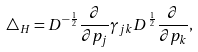Convert formula to latex. <formula><loc_0><loc_0><loc_500><loc_500>\triangle _ { H } = D ^ { - \frac { 1 } { 2 } } \frac { \partial } { \partial p _ { j } } \gamma _ { j k } D ^ { \frac { 1 } { 2 } } \frac { \partial } { \partial p _ { k } } ,</formula> 